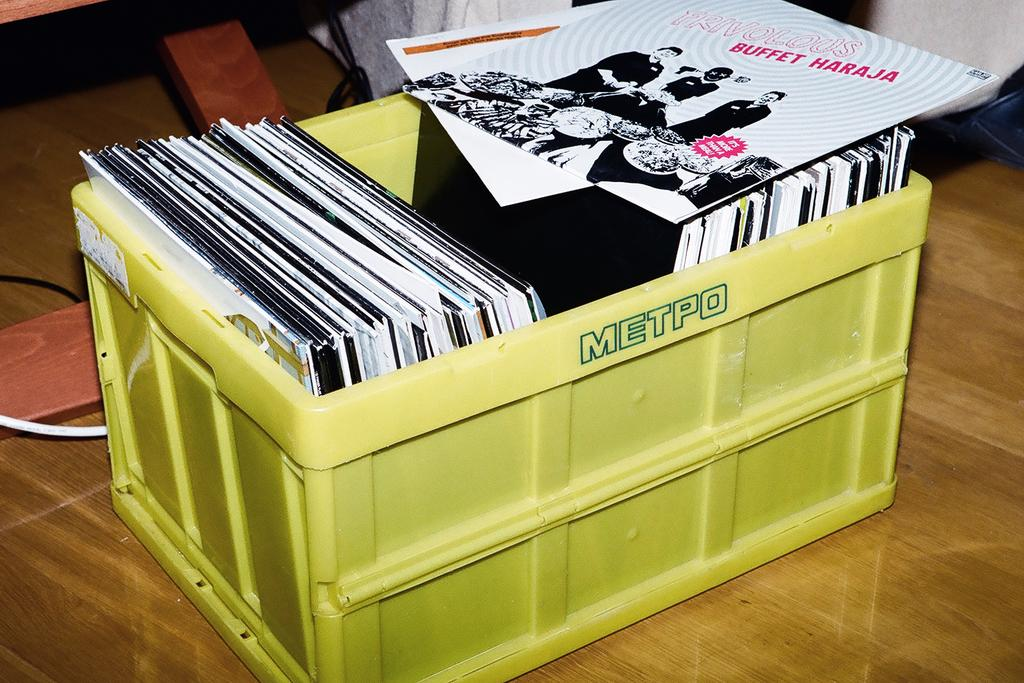<image>
Render a clear and concise summary of the photo. a box of records with the word Metpo on it 